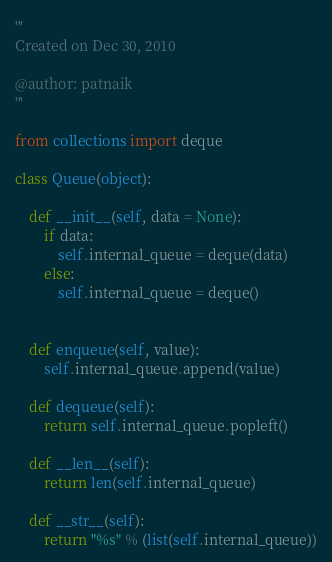Convert code to text. <code><loc_0><loc_0><loc_500><loc_500><_Python_>'''
Created on Dec 30, 2010

@author: patnaik
'''

from collections import deque

class Queue(object):
    
    def __init__(self, data = None):
        if data:
            self.internal_queue = deque(data)
        else:
            self.internal_queue = deque()
        
    
    def enqueue(self, value):
        self.internal_queue.append(value)
        
    def dequeue(self):
        return self.internal_queue.popleft()
        
    def __len__(self):
        return len(self.internal_queue)
    
    def __str__(self):
        return "%s" % (list(self.internal_queue))</code> 